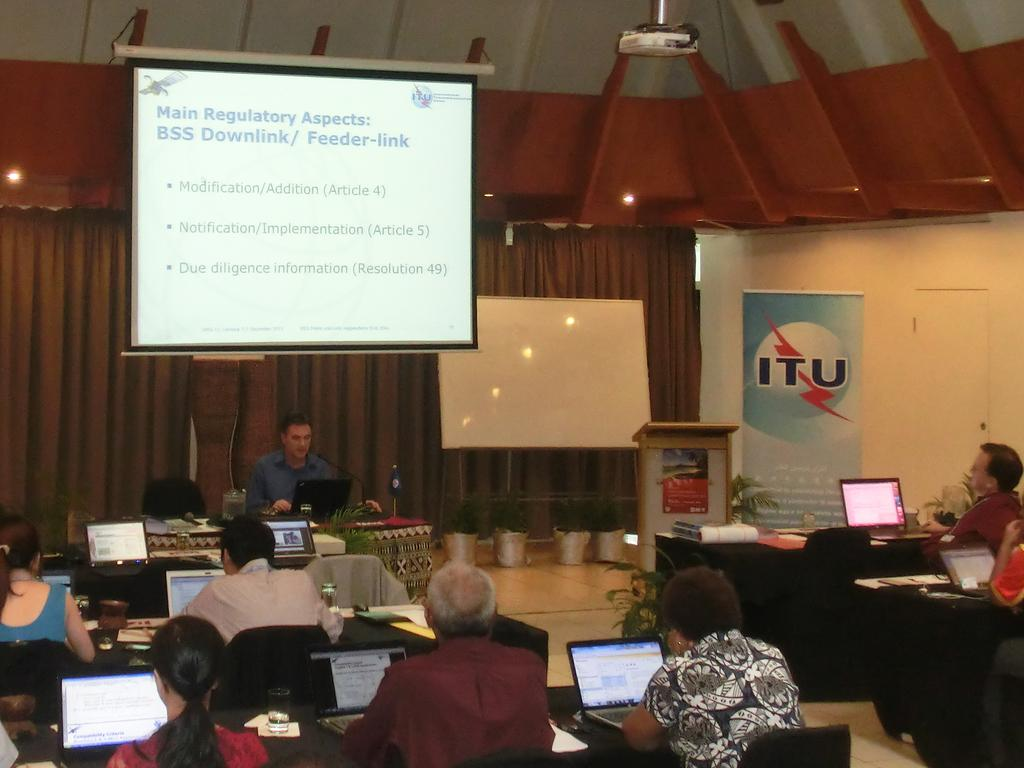<image>
Describe the image concisely. People watching someone teach with a sign on the side that says ITU. 